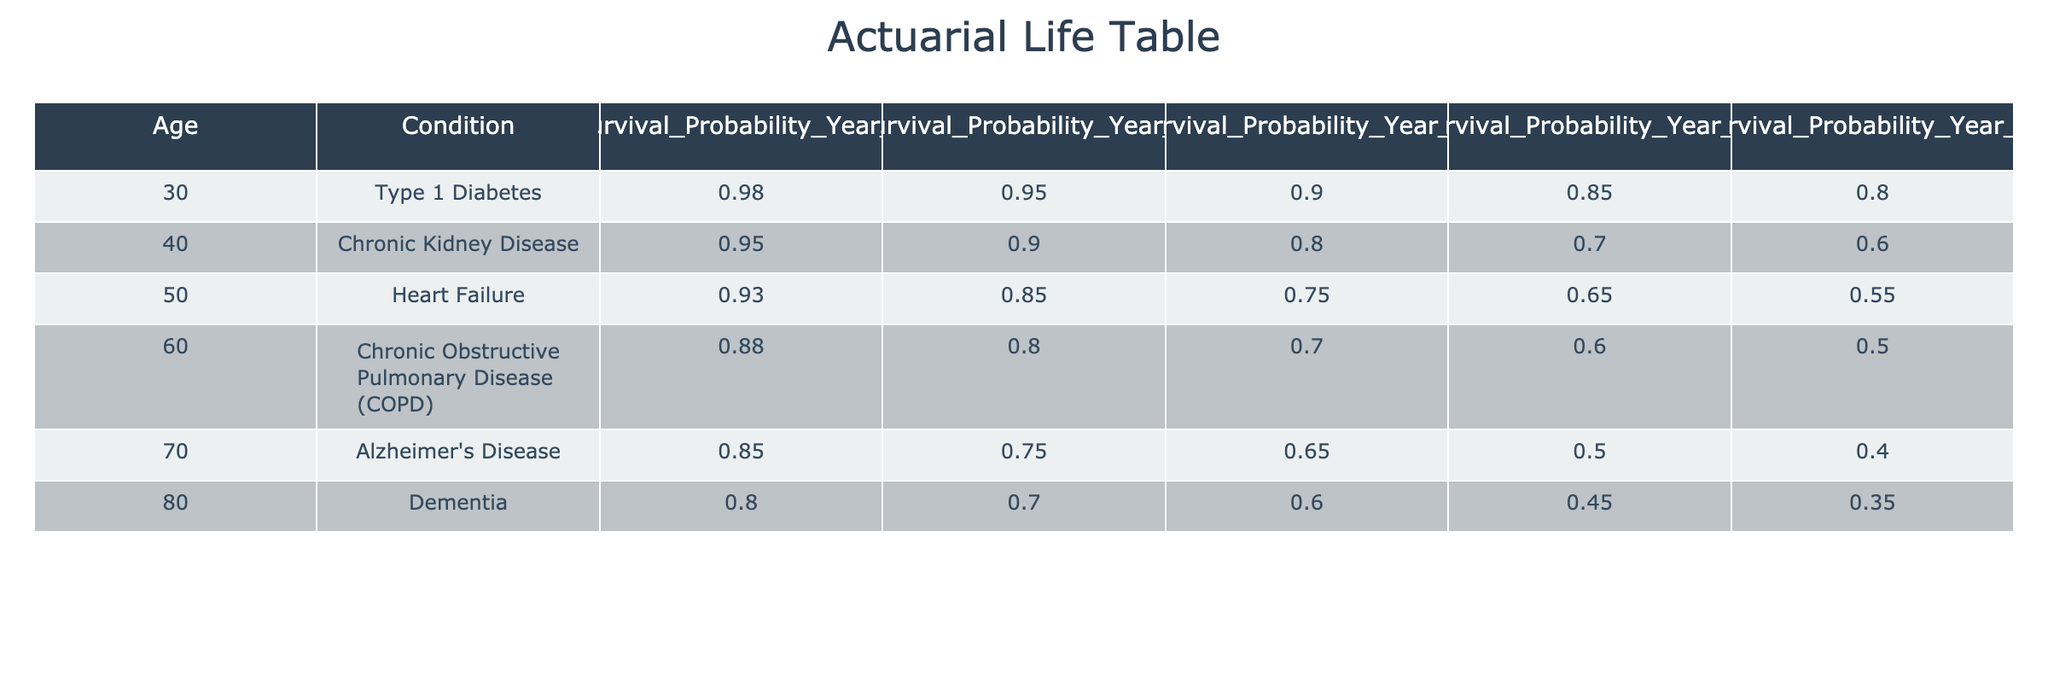What is the survival probability for a 40-year-old with Chronic Kidney Disease after 10 years? According to the table, the survival probability for a 40-year-old with Chronic Kidney Disease after 10 years is listed as 0.80.
Answer: 0.80 What is the survival probability for an 80-year-old with Dementia after 5 years? The table shows that the survival probability for an 80-year-old with Dementia after 5 years is 0.70.
Answer: 0.70 Is the survival probability for a 60-year-old with Chronic Obstructive Pulmonary Disease after 15 years greater than that for a 70-year-old with Alzheimer's Disease after 5 years? From the table, the survival probability for a 60-year-old with COPD after 15 years is 0.60, while for a 70-year-old with Alzheimer's Disease after 5 years, it is 0.75. Since 0.60 is less than 0.75, the statement is false.
Answer: No What is the survival probability for a 50-year-old with Heart Failure after 1 year? The table indicates that a 50-year-old with Heart Failure has a survival probability of 0.93 after 1 year.
Answer: 0.93 What is the average survival probability after 20 years across all conditions listed? To calculate the average, sum all the survival probabilities after 20 years: 0.80 + 0.60 + 0.55 + 0.50 + 0.40 + 0.35 = 3.20. There are 6 conditions, so the average is 3.20 / 6 = 0.5333 (or approximately 0.53).
Answer: 0.53 What is the difference in survival probability after 10 years between a 30-year-old with Type 1 Diabetes and a 60-year-old with Chronic Obstructive Pulmonary Disease? For a 30-year-old with Type 1 Diabetes, the probability is 0.90. For a 60-year-old with COPD, the probability is 0.70. The difference is 0.90 - 0.70 = 0.20.
Answer: 0.20 Does a 40-year-old with Chronic Kidney Disease have a better survival probability after 1 year compared to an 80-year-old with Dementia? The survival probability for a 40-year-old with Chronic Kidney Disease after 1 year is 0.95, while for an 80-year-old with Dementia it is only 0.80. Since 0.95 is greater than 0.80, the statement is true.
Answer: Yes What is the survival probability for a 70-year-old with Alzheimer's Disease after 20 years? The table shows that for a 70-year-old with Alzheimer's Disease, the survival probability after 20 years is 0.40.
Answer: 0.40 